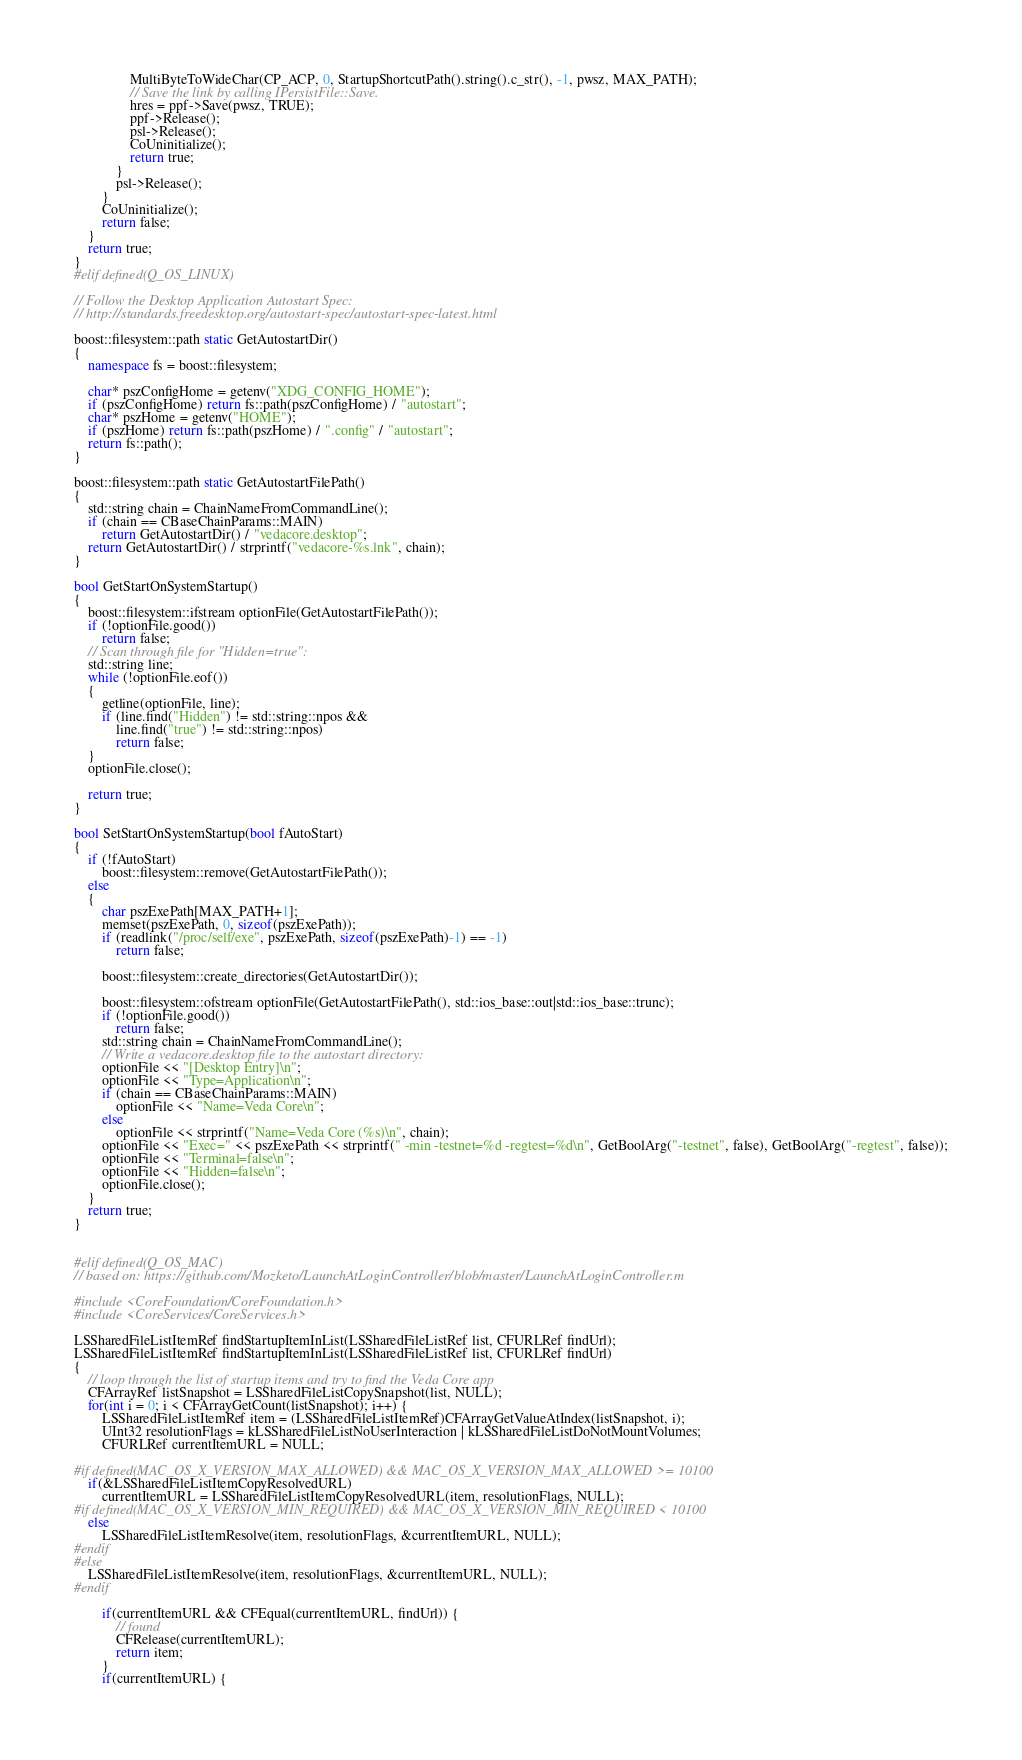<code> <loc_0><loc_0><loc_500><loc_500><_C++_>                MultiByteToWideChar(CP_ACP, 0, StartupShortcutPath().string().c_str(), -1, pwsz, MAX_PATH);
                // Save the link by calling IPersistFile::Save.
                hres = ppf->Save(pwsz, TRUE);
                ppf->Release();
                psl->Release();
                CoUninitialize();
                return true;
            }
            psl->Release();
        }
        CoUninitialize();
        return false;
    }
    return true;
}
#elif defined(Q_OS_LINUX)

// Follow the Desktop Application Autostart Spec:
// http://standards.freedesktop.org/autostart-spec/autostart-spec-latest.html

boost::filesystem::path static GetAutostartDir()
{
    namespace fs = boost::filesystem;

    char* pszConfigHome = getenv("XDG_CONFIG_HOME");
    if (pszConfigHome) return fs::path(pszConfigHome) / "autostart";
    char* pszHome = getenv("HOME");
    if (pszHome) return fs::path(pszHome) / ".config" / "autostart";
    return fs::path();
}

boost::filesystem::path static GetAutostartFilePath()
{
    std::string chain = ChainNameFromCommandLine();
    if (chain == CBaseChainParams::MAIN)
        return GetAutostartDir() / "vedacore.desktop";
    return GetAutostartDir() / strprintf("vedacore-%s.lnk", chain);
}

bool GetStartOnSystemStartup()
{
    boost::filesystem::ifstream optionFile(GetAutostartFilePath());
    if (!optionFile.good())
        return false;
    // Scan through file for "Hidden=true":
    std::string line;
    while (!optionFile.eof())
    {
        getline(optionFile, line);
        if (line.find("Hidden") != std::string::npos &&
            line.find("true") != std::string::npos)
            return false;
    }
    optionFile.close();

    return true;
}

bool SetStartOnSystemStartup(bool fAutoStart)
{
    if (!fAutoStart)
        boost::filesystem::remove(GetAutostartFilePath());
    else
    {
        char pszExePath[MAX_PATH+1];
        memset(pszExePath, 0, sizeof(pszExePath));
        if (readlink("/proc/self/exe", pszExePath, sizeof(pszExePath)-1) == -1)
            return false;

        boost::filesystem::create_directories(GetAutostartDir());

        boost::filesystem::ofstream optionFile(GetAutostartFilePath(), std::ios_base::out|std::ios_base::trunc);
        if (!optionFile.good())
            return false;
        std::string chain = ChainNameFromCommandLine();
        // Write a vedacore.desktop file to the autostart directory:
        optionFile << "[Desktop Entry]\n";
        optionFile << "Type=Application\n";
        if (chain == CBaseChainParams::MAIN)
            optionFile << "Name=Veda Core\n";
        else
            optionFile << strprintf("Name=Veda Core (%s)\n", chain);
        optionFile << "Exec=" << pszExePath << strprintf(" -min -testnet=%d -regtest=%d\n", GetBoolArg("-testnet", false), GetBoolArg("-regtest", false));
        optionFile << "Terminal=false\n";
        optionFile << "Hidden=false\n";
        optionFile.close();
    }
    return true;
}


#elif defined(Q_OS_MAC)
// based on: https://github.com/Mozketo/LaunchAtLoginController/blob/master/LaunchAtLoginController.m

#include <CoreFoundation/CoreFoundation.h>
#include <CoreServices/CoreServices.h>

LSSharedFileListItemRef findStartupItemInList(LSSharedFileListRef list, CFURLRef findUrl);
LSSharedFileListItemRef findStartupItemInList(LSSharedFileListRef list, CFURLRef findUrl)
{
    // loop through the list of startup items and try to find the Veda Core app
    CFArrayRef listSnapshot = LSSharedFileListCopySnapshot(list, NULL);
    for(int i = 0; i < CFArrayGetCount(listSnapshot); i++) {
        LSSharedFileListItemRef item = (LSSharedFileListItemRef)CFArrayGetValueAtIndex(listSnapshot, i);
        UInt32 resolutionFlags = kLSSharedFileListNoUserInteraction | kLSSharedFileListDoNotMountVolumes;
        CFURLRef currentItemURL = NULL;

#if defined(MAC_OS_X_VERSION_MAX_ALLOWED) && MAC_OS_X_VERSION_MAX_ALLOWED >= 10100
    if(&LSSharedFileListItemCopyResolvedURL)
        currentItemURL = LSSharedFileListItemCopyResolvedURL(item, resolutionFlags, NULL);
#if defined(MAC_OS_X_VERSION_MIN_REQUIRED) && MAC_OS_X_VERSION_MIN_REQUIRED < 10100
    else
        LSSharedFileListItemResolve(item, resolutionFlags, &currentItemURL, NULL);
#endif
#else
    LSSharedFileListItemResolve(item, resolutionFlags, &currentItemURL, NULL);
#endif

        if(currentItemURL && CFEqual(currentItemURL, findUrl)) {
            // found
            CFRelease(currentItemURL);
            return item;
        }
        if(currentItemURL) {</code> 